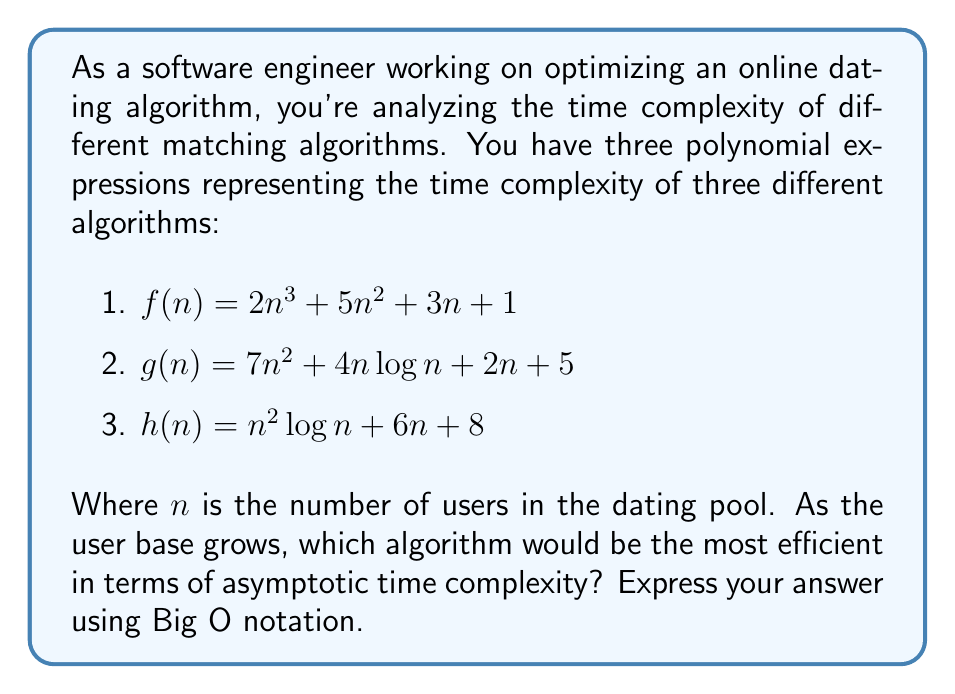Can you answer this question? To determine the most efficient algorithm in terms of asymptotic time complexity, we need to analyze the highest-order term of each polynomial expression, as this term dominates the growth rate as $n$ approaches infinity.

Let's examine each algorithm:

1. $f(n) = 2n^3 + 5n^2 + 3n + 1$
   The highest-order term is $2n^3$, so $f(n) \in O(n^3)$.

2. $g(n) = 7n^2 + 4n\log n + 2n + 5$
   The highest-order term is $7n^2$, so $g(n) \in O(n^2)$.

3. $h(n) = n^2\log n + 6n + 8$
   The highest-order term is $n^2\log n$, so $h(n) \in O(n^2\log n)$.

Now, let's compare the growth rates:

$O(n^3) > O(n^2\log n) > O(n^2)$

This is because:
- $n^3$ grows faster than $n^2\log n$ for large $n$.
- $n^2\log n$ grows faster than $n^2$ for large $n$, albeit only by a logarithmic factor.

Therefore, the algorithm with the lowest (best) time complexity is $g(n)$, which has a time complexity of $O(n^2)$.
Answer: $O(n^2)$ 